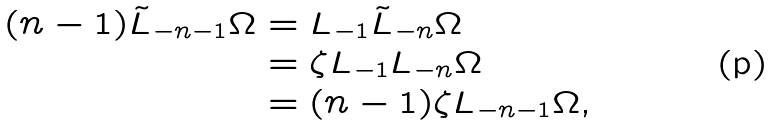<formula> <loc_0><loc_0><loc_500><loc_500>( n - 1 ) \tilde { L } _ { - n - 1 } \Omega & = L _ { - 1 } \tilde { L } _ { - n } \Omega \\ & = \zeta L _ { - 1 } L _ { - n } \Omega \\ & = ( n - 1 ) \zeta L _ { - n - 1 } \Omega ,</formula> 